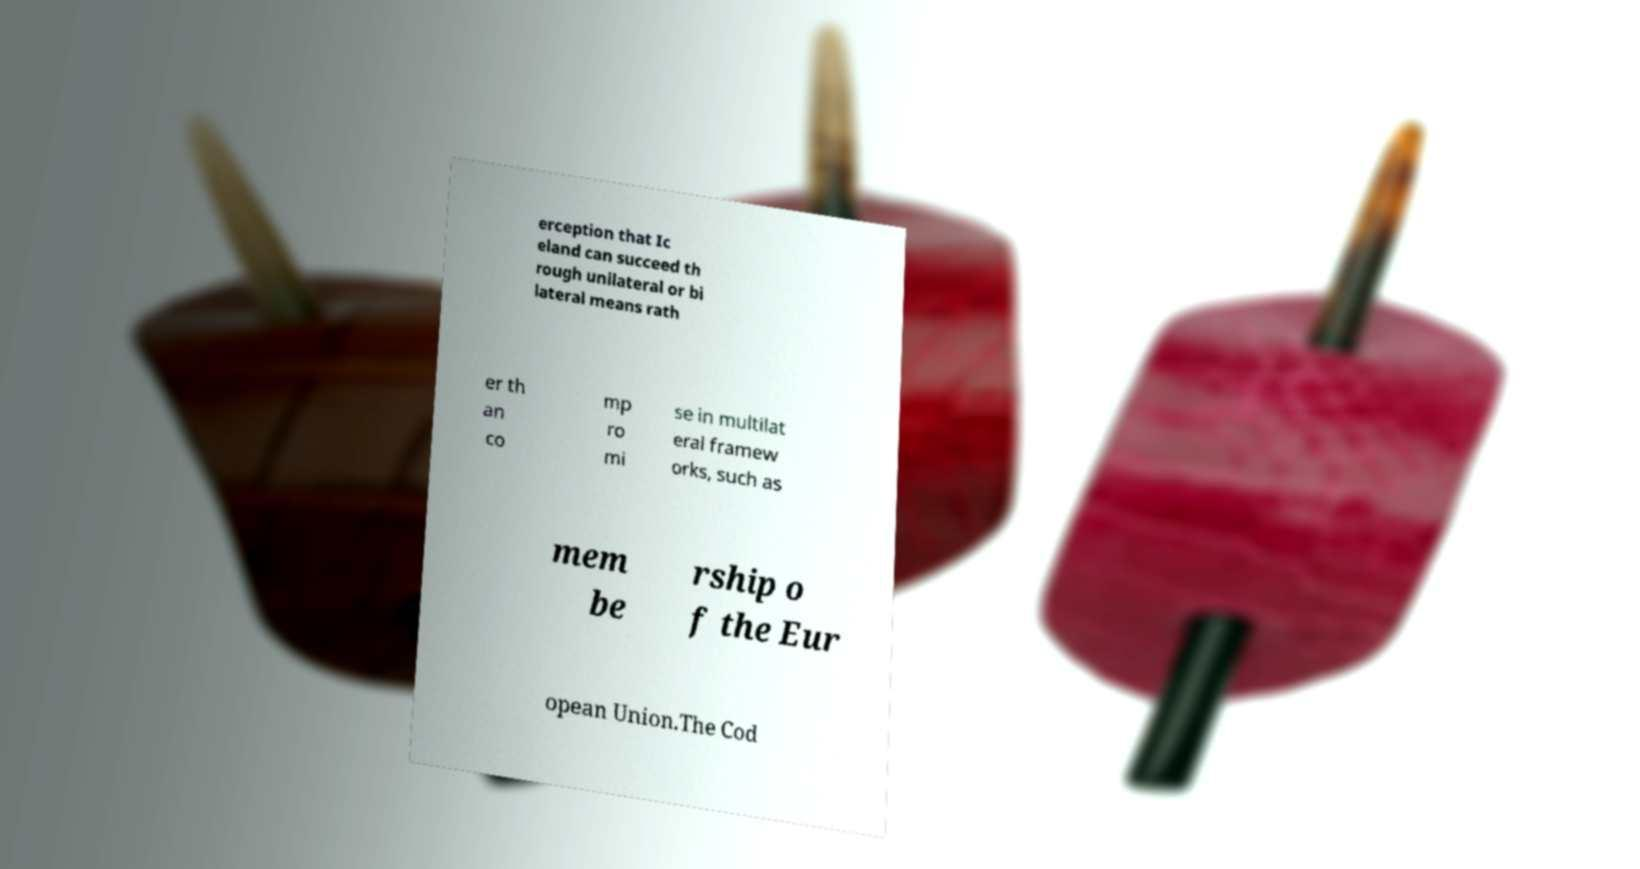For documentation purposes, I need the text within this image transcribed. Could you provide that? erception that Ic eland can succeed th rough unilateral or bi lateral means rath er th an co mp ro mi se in multilat eral framew orks, such as mem be rship o f the Eur opean Union.The Cod 